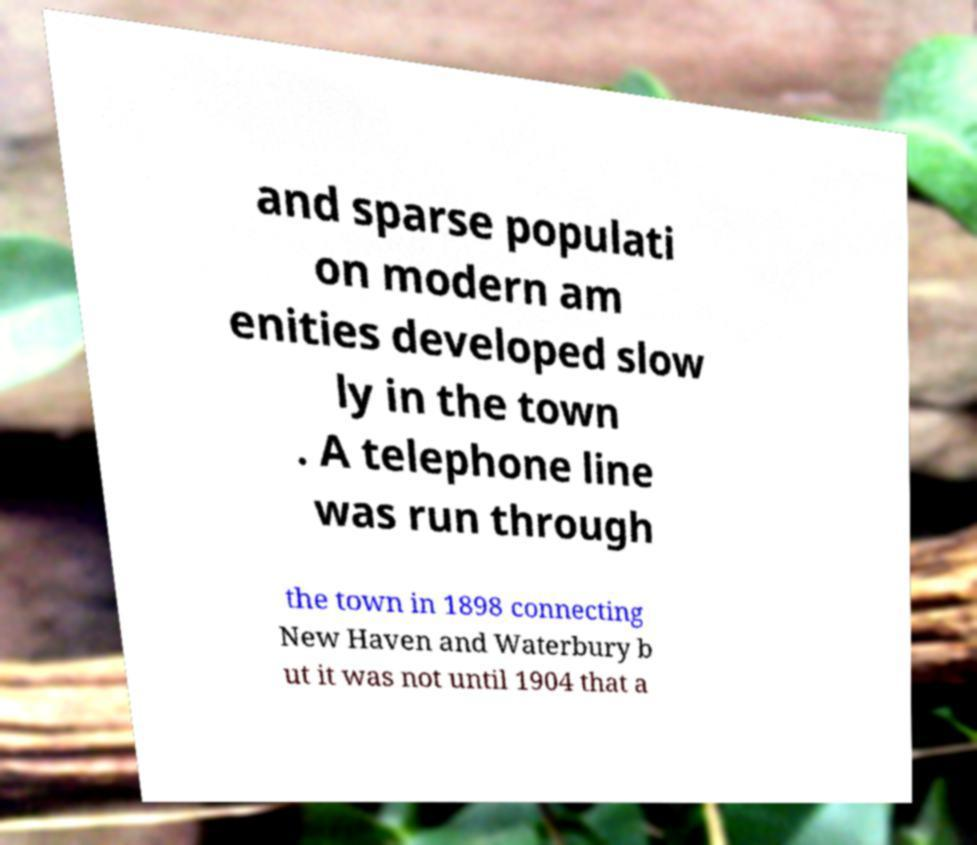Could you assist in decoding the text presented in this image and type it out clearly? and sparse populati on modern am enities developed slow ly in the town . A telephone line was run through the town in 1898 connecting New Haven and Waterbury b ut it was not until 1904 that a 